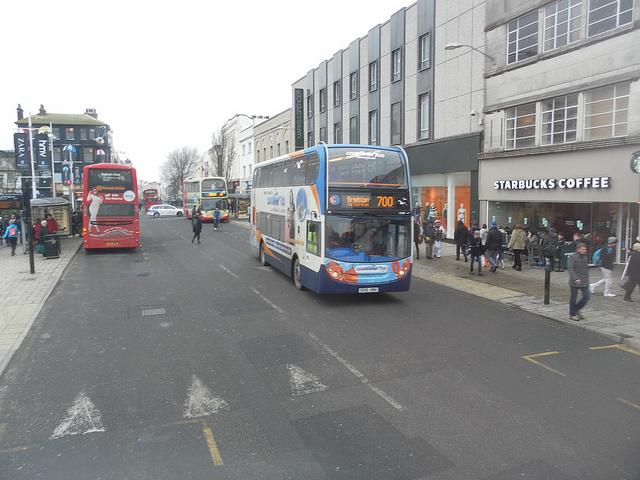What coffee shop is in the picture?
Be succinct. Starbucks. What time of day is it?
Give a very brief answer. Morning. How many cars have decors in  the foto?
Short answer required. 0. What number is on the first bus?
Keep it brief. 700. 